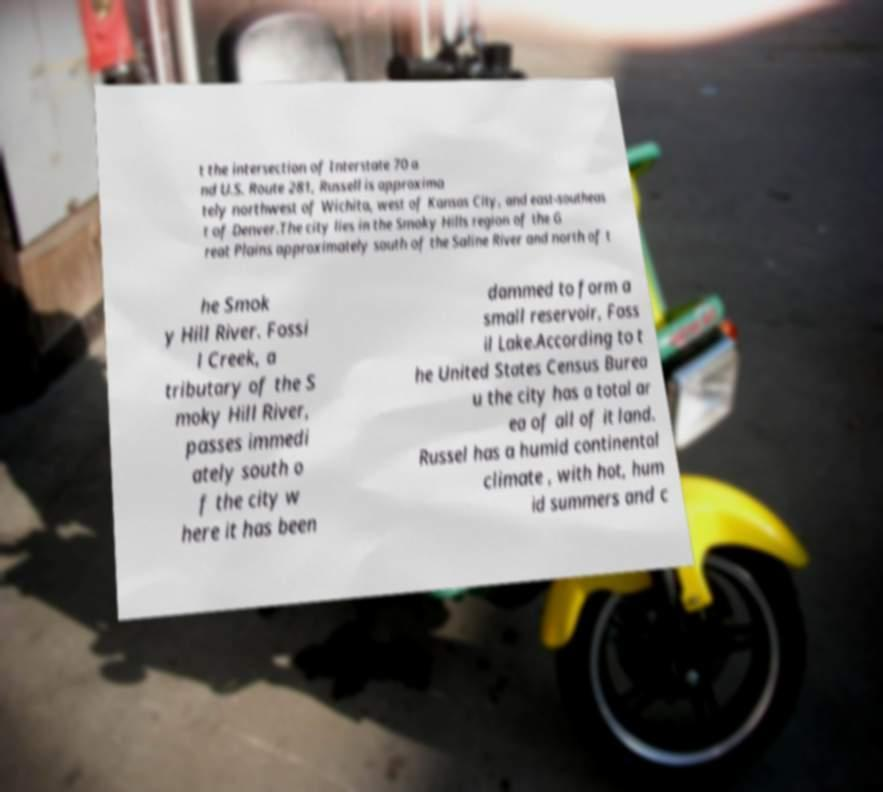What messages or text are displayed in this image? I need them in a readable, typed format. t the intersection of Interstate 70 a nd U.S. Route 281, Russell is approxima tely northwest of Wichita, west of Kansas City, and east-southeas t of Denver.The city lies in the Smoky Hills region of the G reat Plains approximately south of the Saline River and north of t he Smok y Hill River. Fossi l Creek, a tributary of the S moky Hill River, passes immedi ately south o f the city w here it has been dammed to form a small reservoir, Foss il Lake.According to t he United States Census Burea u the city has a total ar ea of all of it land. Russel has a humid continental climate , with hot, hum id summers and c 